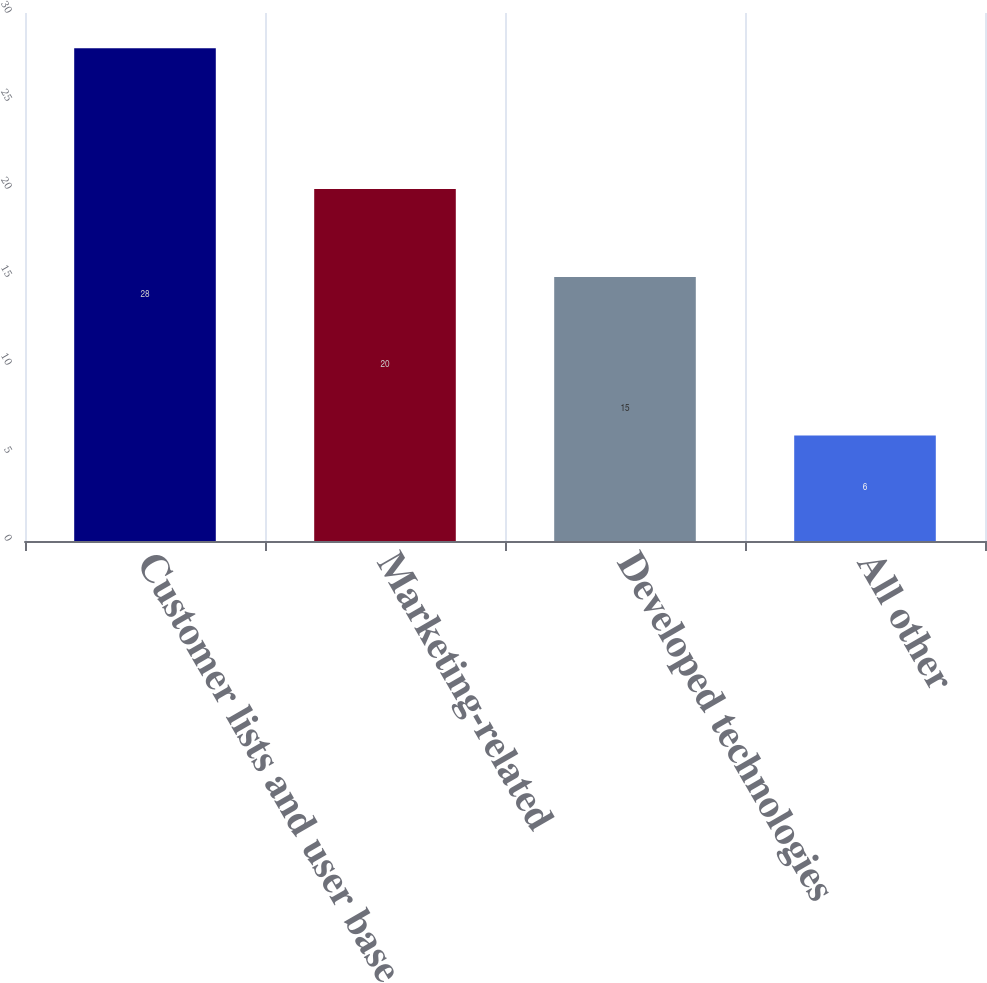Convert chart. <chart><loc_0><loc_0><loc_500><loc_500><bar_chart><fcel>Customer lists and user base<fcel>Marketing-related<fcel>Developed technologies<fcel>All other<nl><fcel>28<fcel>20<fcel>15<fcel>6<nl></chart> 